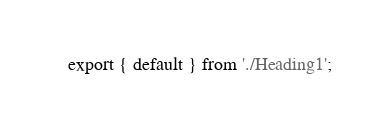Convert code to text. <code><loc_0><loc_0><loc_500><loc_500><_TypeScript_>export { default } from './Heading1';
</code> 